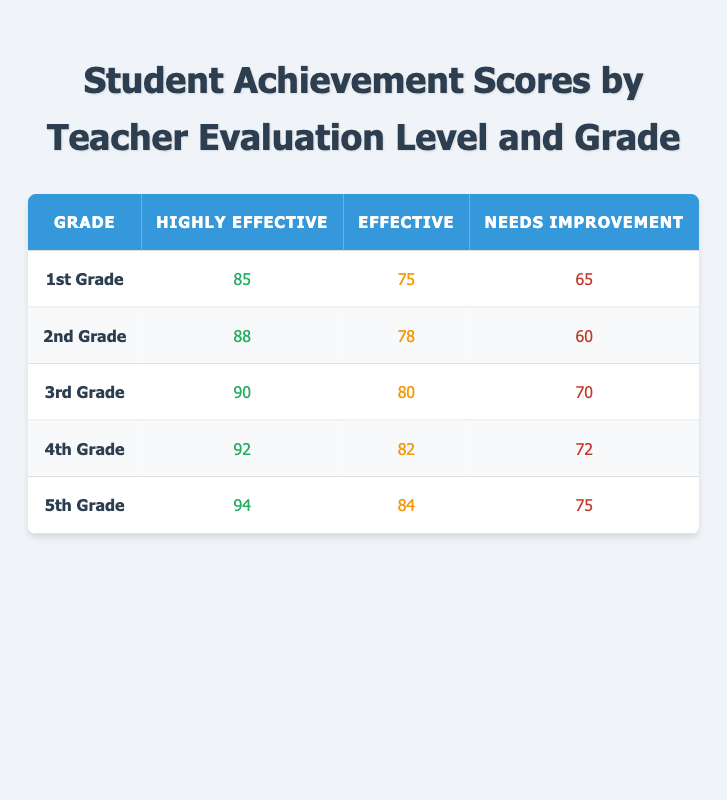What is the average achievement score for the 1st Grade students evaluated as Highly Effective? The data shows that the average achievement score for the 1st Grade students with a Highly Effective evaluation level is 85.
Answer: 85 What is the average achievement score for 4th Grade students with Needs Improvement evaluations? The table shows that the average achievement score for 4th Grade students evaluated as Needs Improvement is 72.
Answer: 72 How many points higher is the average achievement score for 5th Grade students with Highly Effective evaluations compared to those with Needs Improvement evaluations? For 5th Grade, the Highly Effective average score is 94, and the Needs Improvement score is 75. The difference is 94 - 75 = 19 points.
Answer: 19 Is the average achievement score for 3rd Grade students with Effective evaluations higher than that for 2nd Grade students with Needs Improvement evaluations? The average for 3rd Grade students with Effective evaluations is 80, and the average for 2nd Grade students with Needs Improvement evaluations is 60. Since 80 is greater than 60, the statement is true.
Answer: Yes What is the total average achievement score for all the Highly Effective evaluations across all grades? The scores for Highly Effective evaluations are: 85 (1st), 88 (2nd), 90 (3rd), 92 (4th), and 94 (5th). The total is 85 + 88 + 90 + 92 + 94 = 449. To find the average, divide by the number of grades (5); 449 / 5 = 89.8.
Answer: 89.8 How does the achievement score for Effective evaluations in 2nd Grade compare to those in 4th Grade? The average achievement score for 2nd Grade with Effective evaluations is 78, while for 4th Grade it is 82. Since 78 is less than 82, the score for 2nd Grade is lower.
Answer: Lower What grade has the highest average achievement score for students with Needs Improvement evaluations? The average scores for Needs Improvement evaluations are: 65 (1st), 60 (2nd), 70 (3rd), 72 (4th), and 75 (5th). The highest score is 75 from the 5th Grade.
Answer: 5th Grade If we only consider Effective evaluations across grades, which grade has the lowest achievement score? The Effective scores are: 75 (1st), 78 (2nd), 80 (3rd), 82 (4th), and 84 (5th). The lowest among these is 75 from the 1st Grade.
Answer: 1st Grade What is the difference in average achievement scores between Highly Effective and Effective evaluations for 3rd Grade? The Highly Effective score for 3rd Grade is 90, and the Effective score is 80. The difference is 90 - 80 = 10.
Answer: 10 